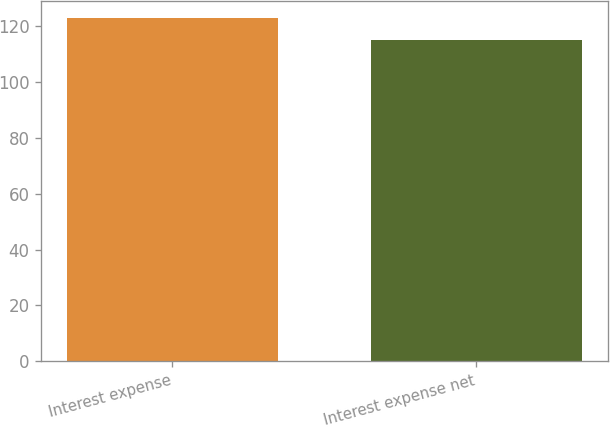Convert chart to OTSL. <chart><loc_0><loc_0><loc_500><loc_500><bar_chart><fcel>Interest expense<fcel>Interest expense net<nl><fcel>123<fcel>115<nl></chart> 